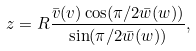<formula> <loc_0><loc_0><loc_500><loc_500>z = R \frac { \bar { v } ( v ) \cos ( \pi / 2 \bar { w } ( w ) ) } { \sin ( \pi / 2 \bar { w } ( w ) ) } ,</formula> 